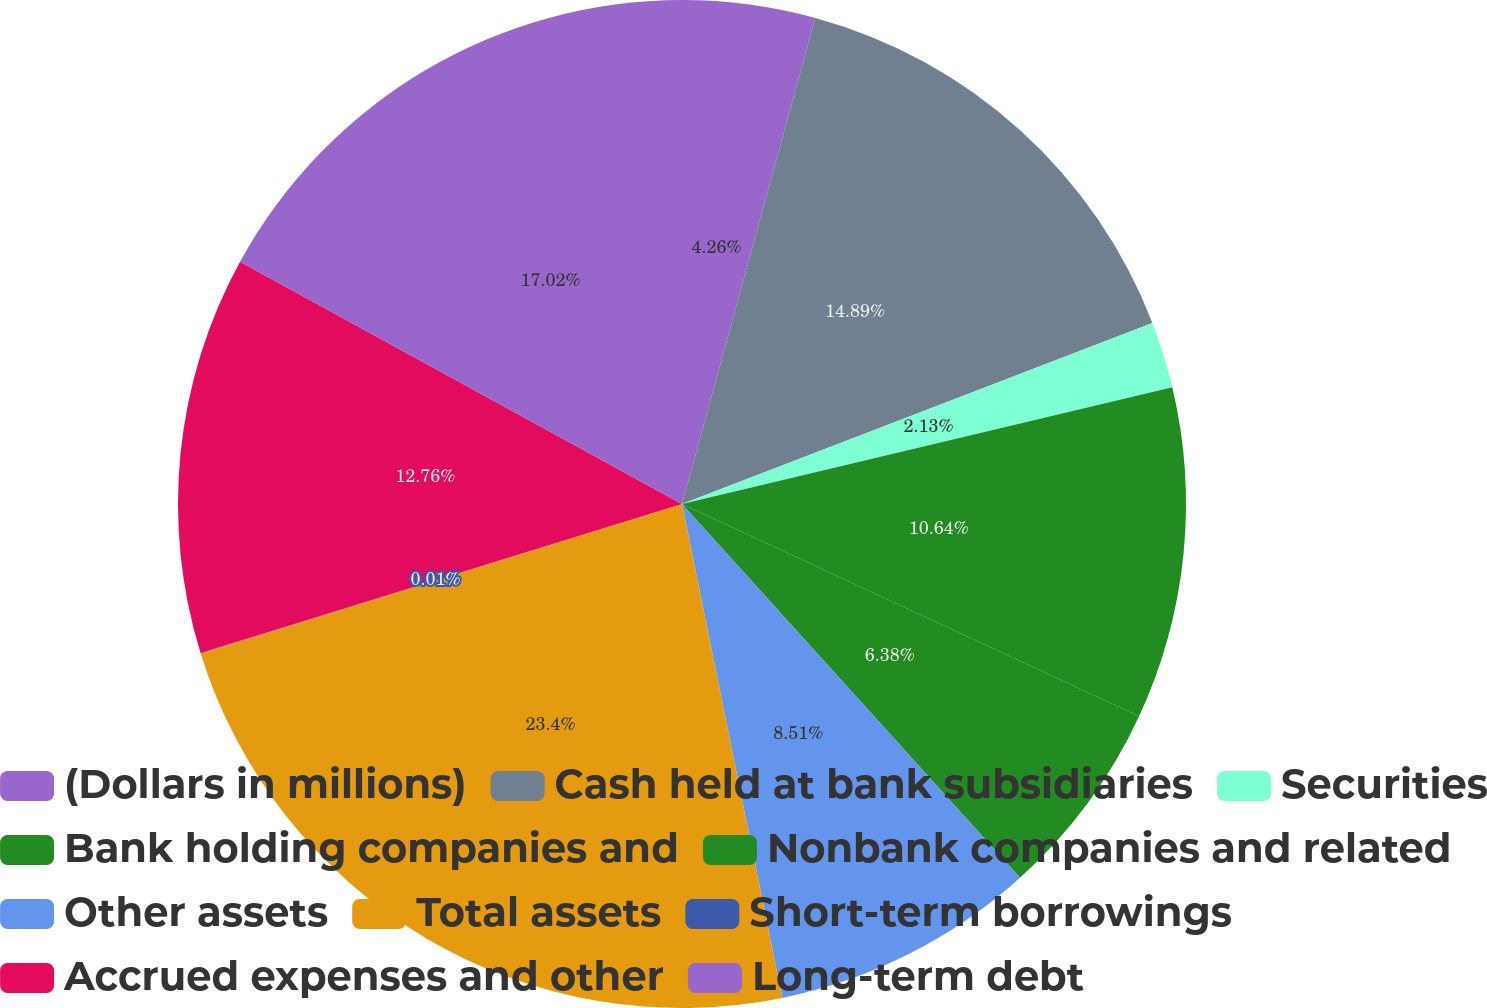Convert chart. <chart><loc_0><loc_0><loc_500><loc_500><pie_chart><fcel>(Dollars in millions)<fcel>Cash held at bank subsidiaries<fcel>Securities<fcel>Bank holding companies and<fcel>Nonbank companies and related<fcel>Other assets<fcel>Total assets<fcel>Short-term borrowings<fcel>Accrued expenses and other<fcel>Long-term debt<nl><fcel>4.26%<fcel>14.89%<fcel>2.13%<fcel>10.64%<fcel>6.38%<fcel>8.51%<fcel>23.4%<fcel>0.01%<fcel>12.76%<fcel>17.02%<nl></chart> 